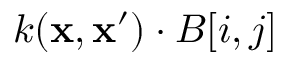Convert formula to latex. <formula><loc_0><loc_0><loc_500><loc_500>k ( x , x ^ { \prime } ) \cdot B [ i , j ]</formula> 